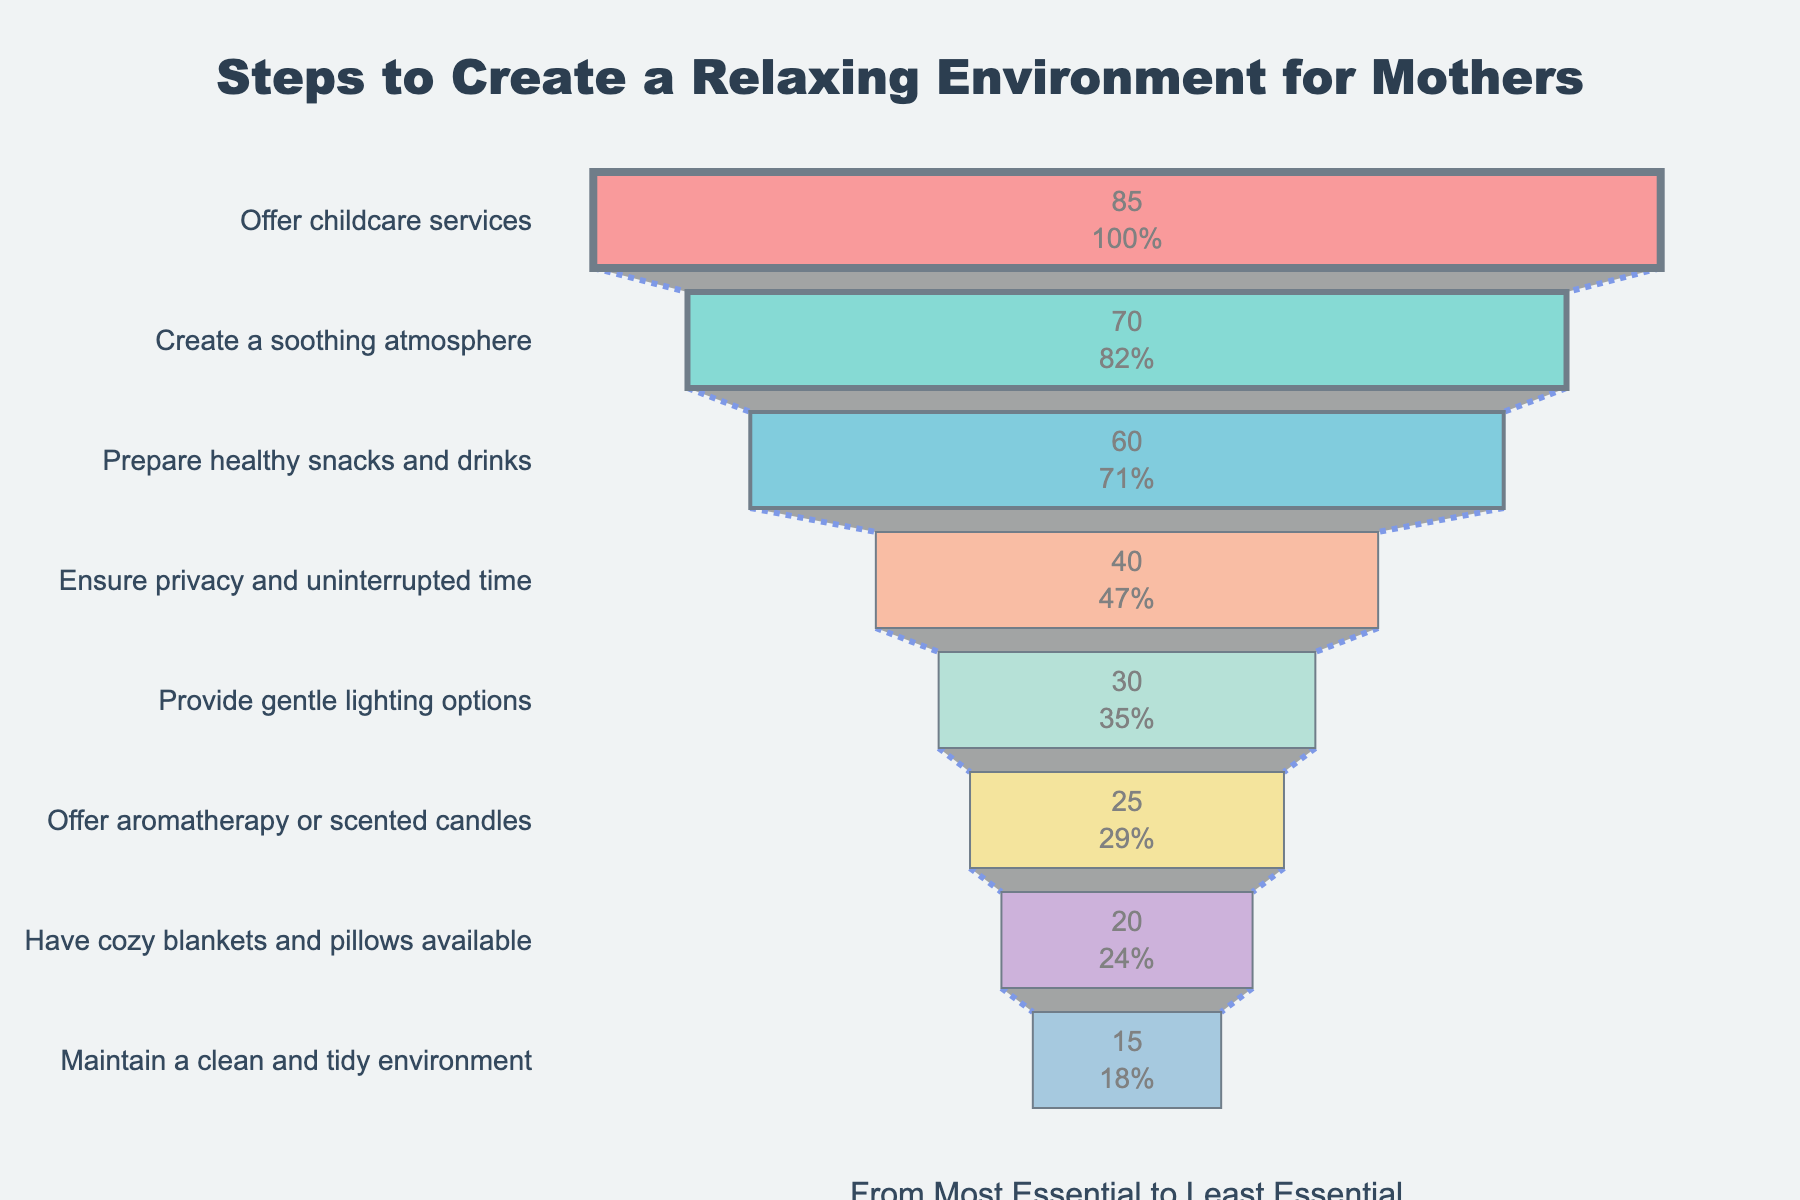what is the importance value for 'Offer childcare services'? The importance value for 'Offer childcare services' can be found on the funnel chart. It is depicted with the highest importance value.
Answer: 85 Which step has the lowest importance in the funnel chart? To find the step with the lowest importance, look at the narrowest part of the funnel chart, which represents the least important step.
Answer: Maintain a clean and tidy environment How much more important is 'Create a soothing atmosphere' compared to 'Ensure privacy and uninterrupted time'? Subtract the importance value of 'Ensure privacy and uninterrupted time' from 'Create a soothing atmosphere'. (70 - 40) = 30
Answer: 30 What percentage of the initial funnel does 'Have cozy blankets and pillows available' represent? The percentage can be observed inside the section for 'Have cozy blankets and pillows available'. It represents 20 divided by the initial total importance of 85 and multiplied by 100.
Answer: 23.5% Which two steps have very close importance values? Compare the values shown in the funnel chart to find any two steps with values close to each other. 'Offer aromatherapy or scented candles' (25) and 'Have cozy blankets and pillows available' (20) are fairly close.
Answer: Offer aromatherapy or scented candles and Have cozy blankets and pillows available What step would come third in order of importance? Observe the sequence in the funnel chart starting from the most essential step to find the third step.
Answer: Prepare healthy snacks and drinks Which steps combined have an importance value of more than 100? Add together the importance values of different combinations of steps to see which sets sum to over 100. Combining 'Offer childcare services' (85) and 'Create a soothing atmosphere' (70) results in more than 100.
Answer: Offer childcare services and Create a soothing atmosphere Which step contributes more to creating a relaxing environment: 'Prepare healthy snacks and drinks' or 'Provide gentle lighting options'? Compare the importance values of the two steps. 'Prepare healthy snacks and drinks' has a greater importance value (60) than 'Provide gentle lighting options' (30).
Answer: Prepare healthy snacks and drinks How many steps have an importance value of less than 30? Count the number of steps in the funnel chart that have an importance value less than 30.
Answer: Three steps 